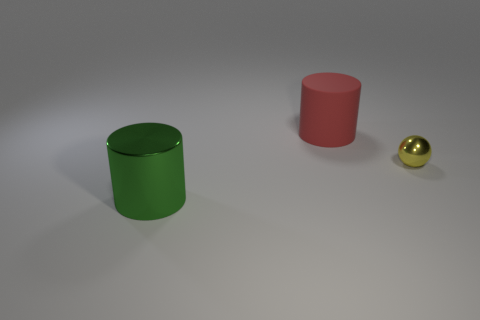Add 2 large green things. How many objects exist? 5 Subtract all cylinders. How many objects are left? 1 Subtract all big rubber things. Subtract all tiny metal spheres. How many objects are left? 1 Add 2 big red cylinders. How many big red cylinders are left? 3 Add 1 large green metallic cylinders. How many large green metallic cylinders exist? 2 Subtract 0 red blocks. How many objects are left? 3 